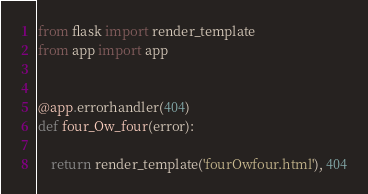<code> <loc_0><loc_0><loc_500><loc_500><_Python_>from flask import render_template
from app import app


@app.errorhandler(404)
def four_Ow_four(error):
   
    return render_template('fourOwfour.html'), 404
</code> 